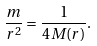Convert formula to latex. <formula><loc_0><loc_0><loc_500><loc_500>\frac { m } { r ^ { 2 } } = \frac { 1 } { 4 M ( r ) } .</formula> 